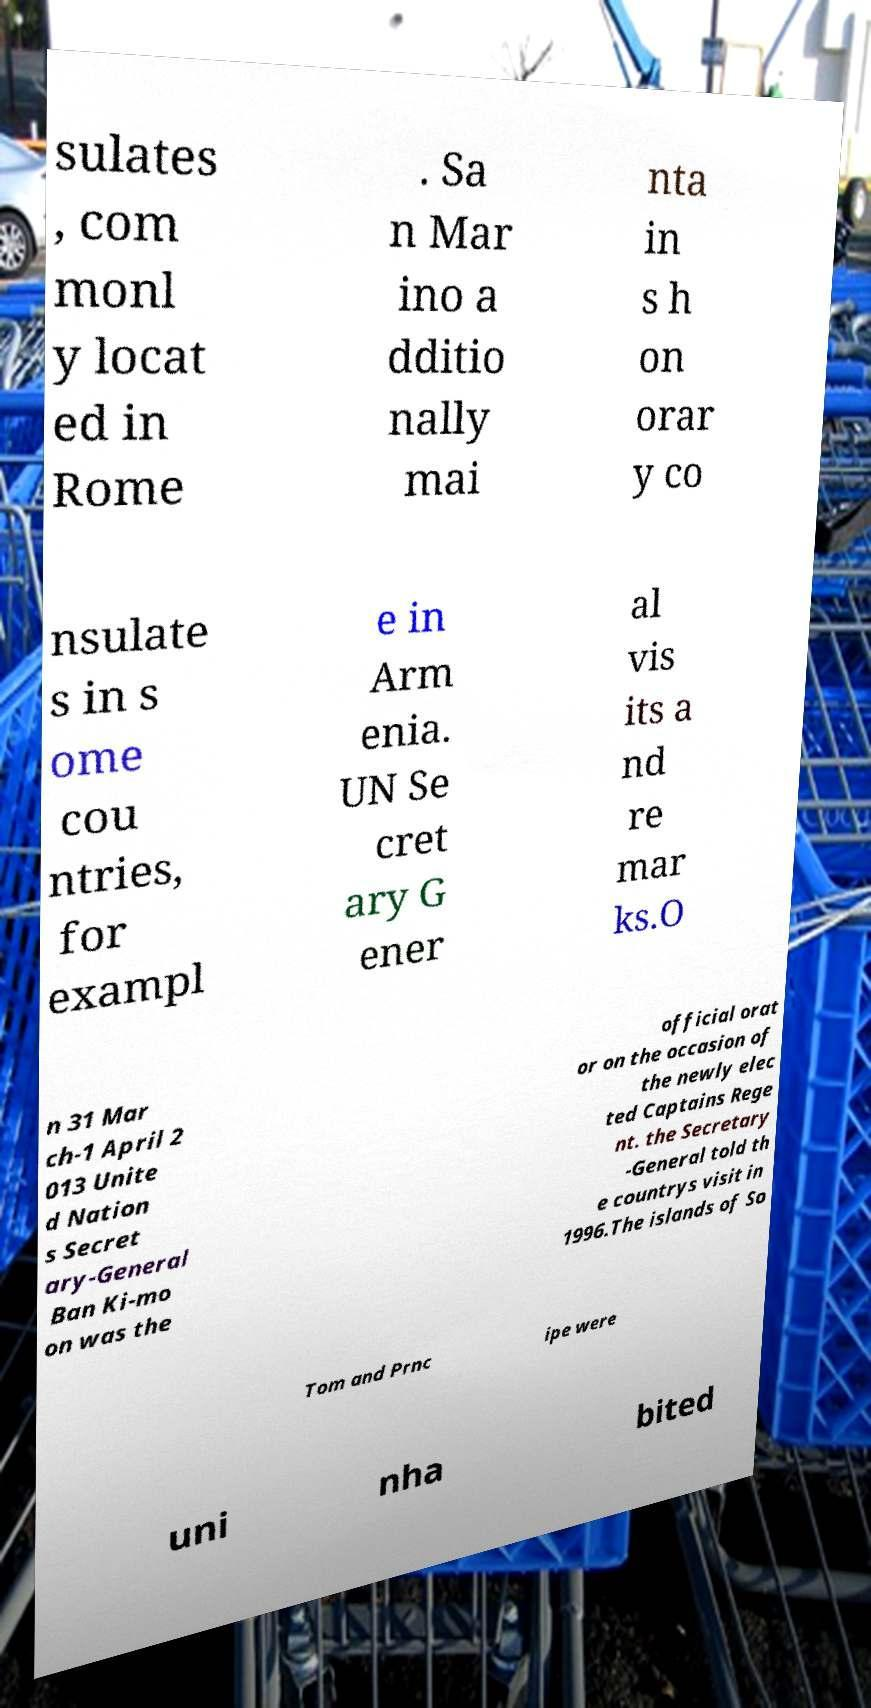Please identify and transcribe the text found in this image. sulates , com monl y locat ed in Rome . Sa n Mar ino a dditio nally mai nta in s h on orar y co nsulate s in s ome cou ntries, for exampl e in Arm enia. UN Se cret ary G ener al vis its a nd re mar ks.O n 31 Mar ch-1 April 2 013 Unite d Nation s Secret ary-General Ban Ki-mo on was the official orat or on the occasion of the newly elec ted Captains Rege nt. the Secretary -General told th e countrys visit in 1996.The islands of So Tom and Prnc ipe were uni nha bited 